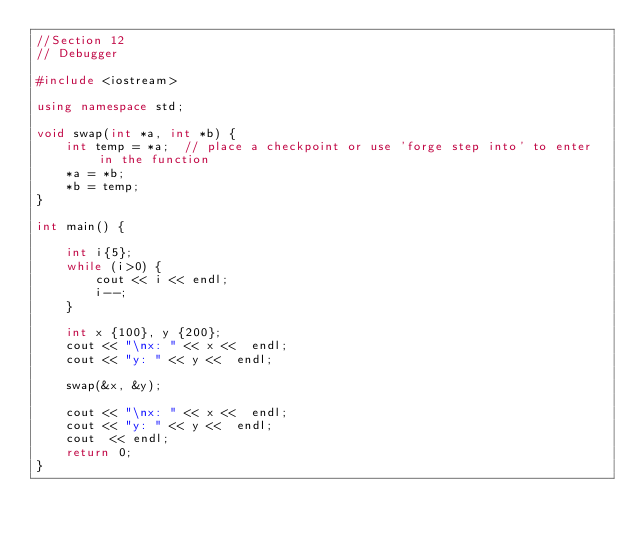<code> <loc_0><loc_0><loc_500><loc_500><_C++_>//Section 12
// Debugger

#include <iostream>

using namespace std;

void swap(int *a, int *b) {
    int temp = *a;  // place a checkpoint or use 'forge step into' to enter in the function
    *a = *b;
    *b = temp;
}

int main() {

    int i{5};
    while (i>0) {
        cout << i << endl;
        i--;
    }

    int x {100}, y {200};
    cout << "\nx: " << x <<  endl;
    cout << "y: " << y <<  endl;

    swap(&x, &y);

    cout << "\nx: " << x <<  endl;
    cout << "y: " << y <<  endl;
    cout  << endl;
    return 0;
}

</code> 